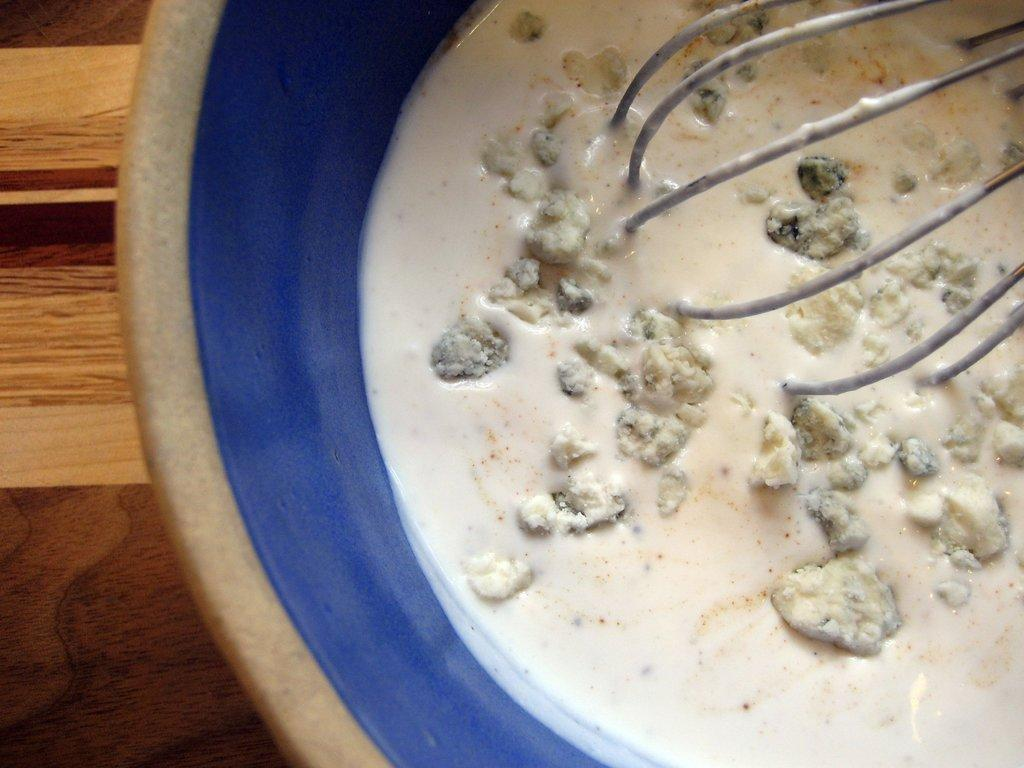What is the main substance in the image? There is a white liquid in the image. What other material is present in the image? There is dough in the image. Where are the white liquid and dough located? The white liquid and dough are in a beaker. What tool is used in the image? A mixing tool is in the image. What surface is the beaker placed on? The beaker is on a wooden table. What type of hope can be seen growing in the pot in the image? There is no pot or hope present in the image; it features a beaker with white liquid and dough. How many screws are visible in the image? There are no screws visible in the image. 